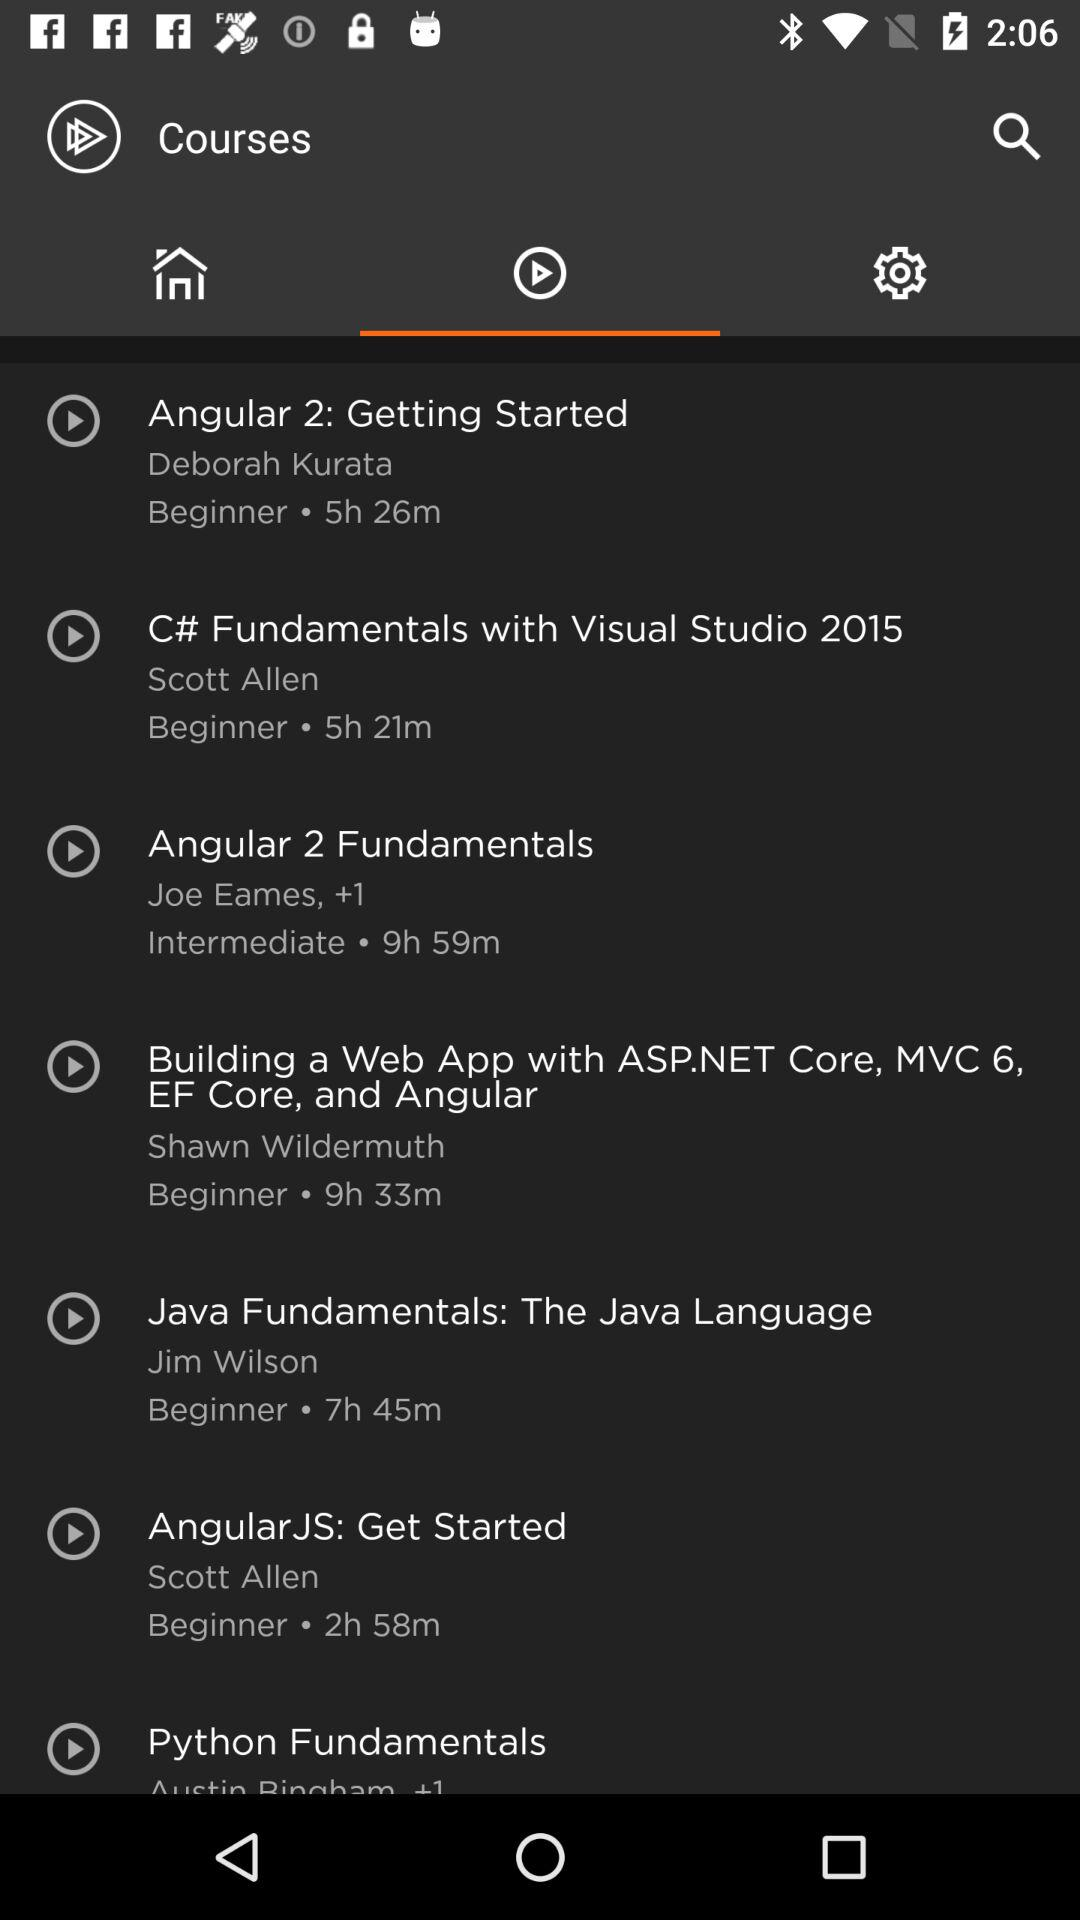What course has a duration of 5 hours and 26 minutes? The course is "Angular 2: Getting Started". 